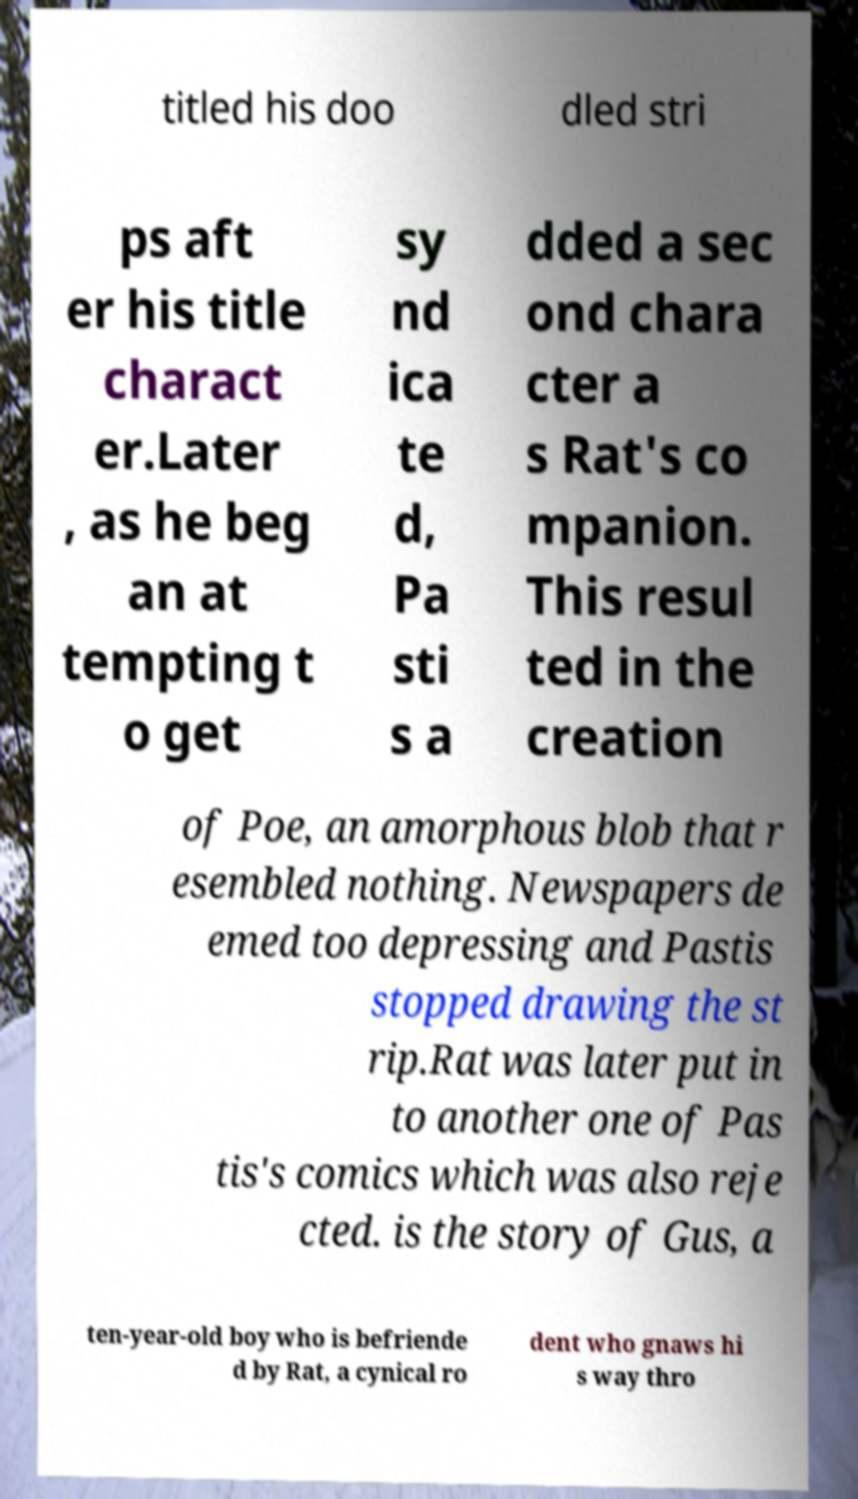For documentation purposes, I need the text within this image transcribed. Could you provide that? titled his doo dled stri ps aft er his title charact er.Later , as he beg an at tempting t o get sy nd ica te d, Pa sti s a dded a sec ond chara cter a s Rat's co mpanion. This resul ted in the creation of Poe, an amorphous blob that r esembled nothing. Newspapers de emed too depressing and Pastis stopped drawing the st rip.Rat was later put in to another one of Pas tis's comics which was also reje cted. is the story of Gus, a ten-year-old boy who is befriende d by Rat, a cynical ro dent who gnaws hi s way thro 